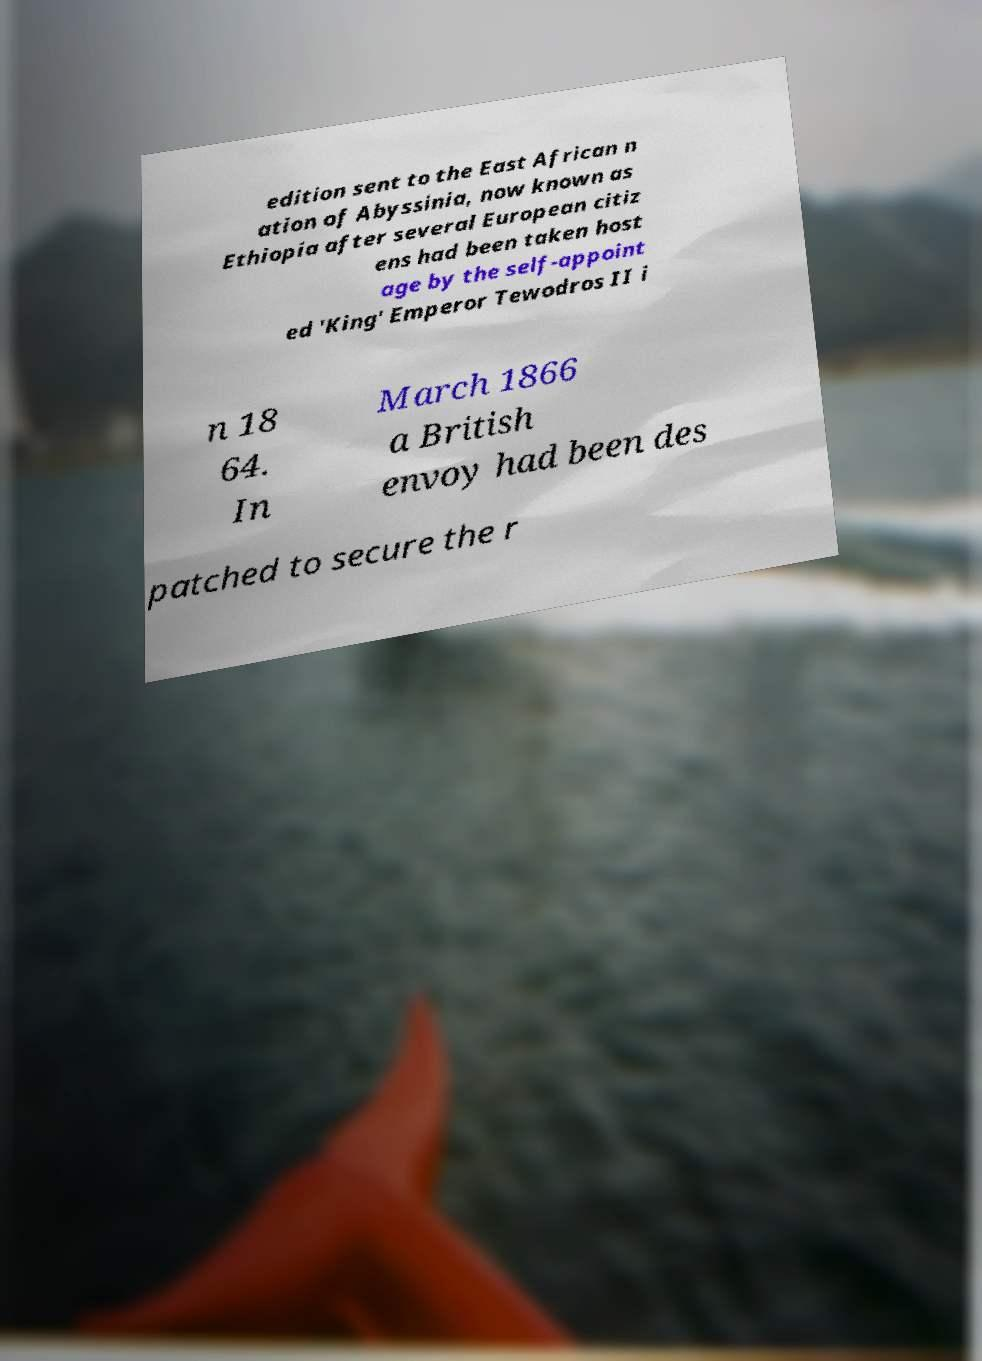Please identify and transcribe the text found in this image. edition sent to the East African n ation of Abyssinia, now known as Ethiopia after several European citiz ens had been taken host age by the self-appoint ed 'King' Emperor Tewodros II i n 18 64. In March 1866 a British envoy had been des patched to secure the r 